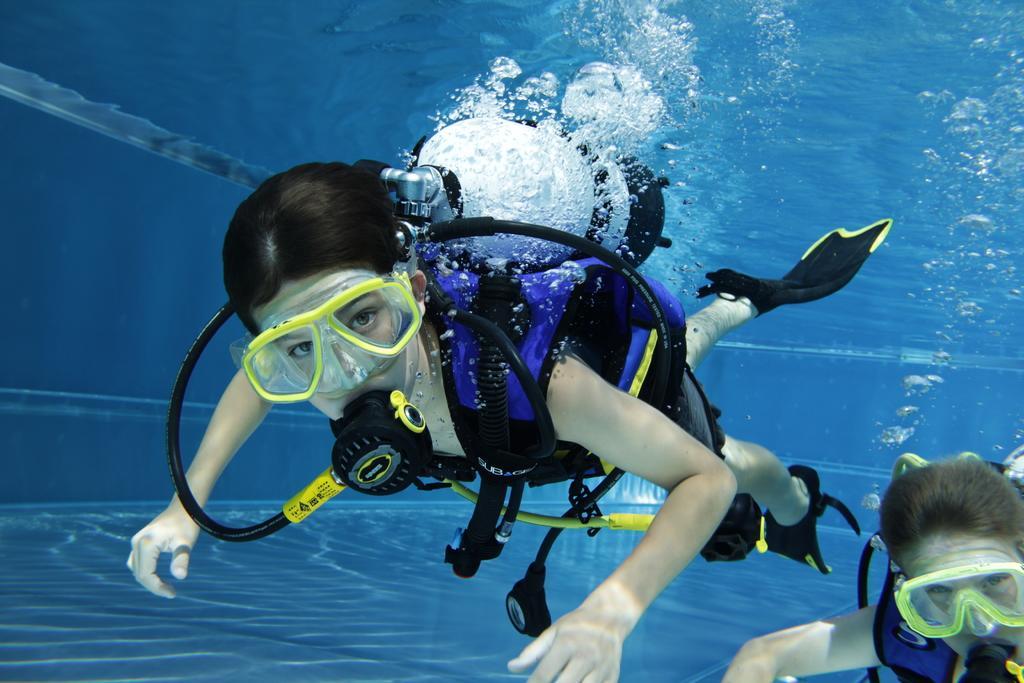Please provide a concise description of this image. In this image, there are two persons wearing oxygen cylinders inside the water. 